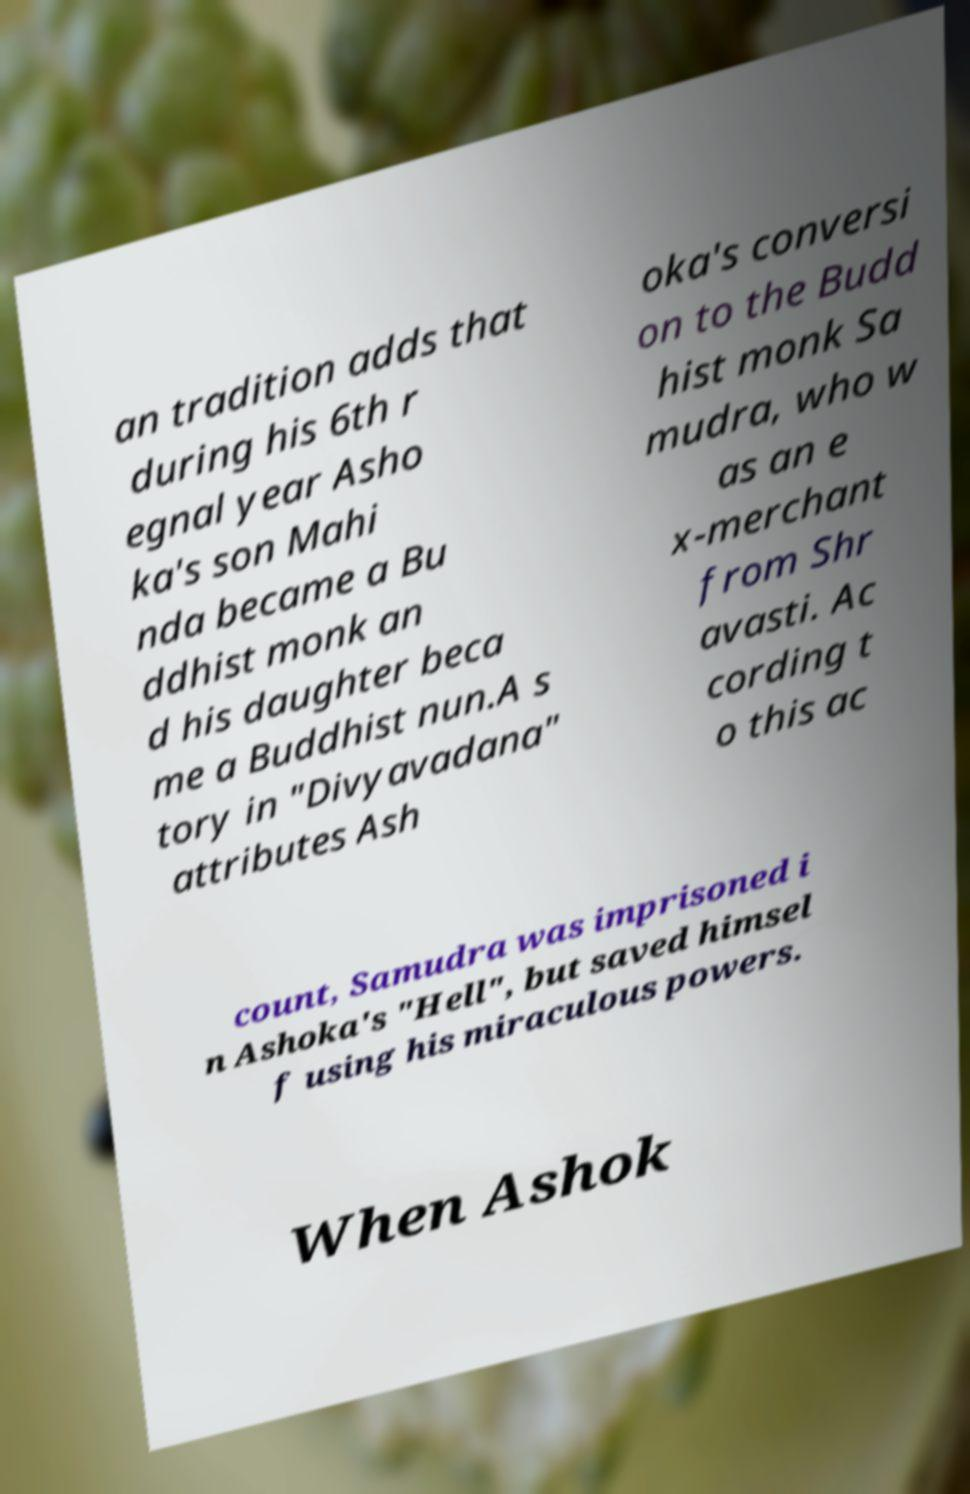Can you read and provide the text displayed in the image?This photo seems to have some interesting text. Can you extract and type it out for me? an tradition adds that during his 6th r egnal year Asho ka's son Mahi nda became a Bu ddhist monk an d his daughter beca me a Buddhist nun.A s tory in "Divyavadana" attributes Ash oka's conversi on to the Budd hist monk Sa mudra, who w as an e x-merchant from Shr avasti. Ac cording t o this ac count, Samudra was imprisoned i n Ashoka's "Hell", but saved himsel f using his miraculous powers. When Ashok 